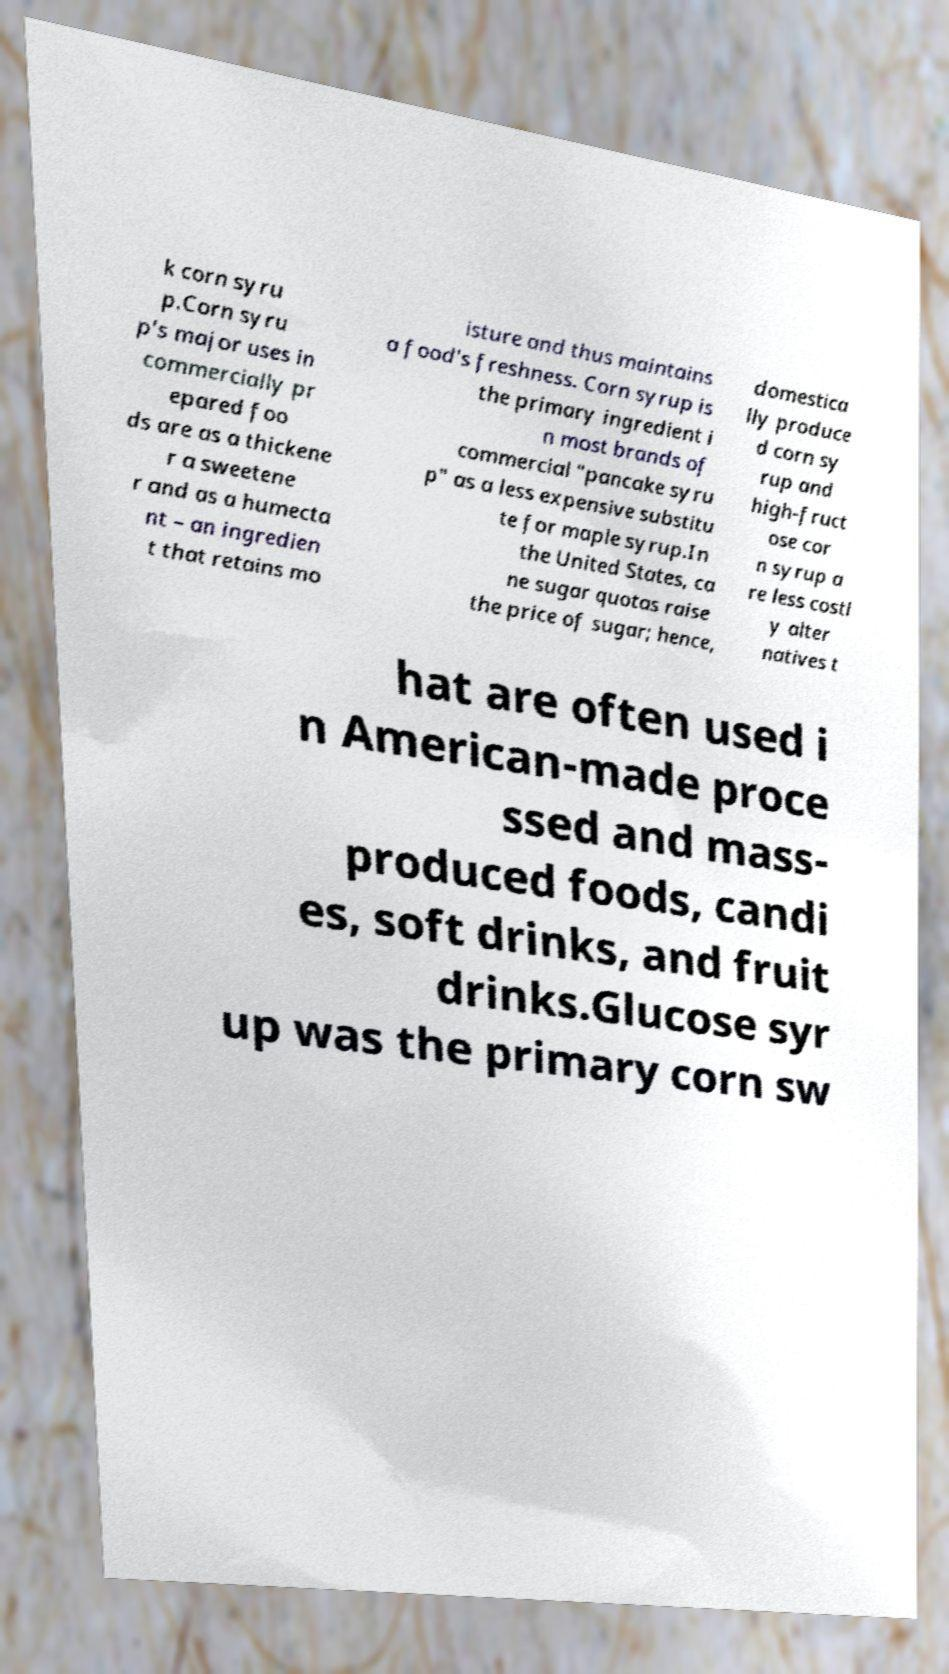Can you accurately transcribe the text from the provided image for me? k corn syru p.Corn syru p's major uses in commercially pr epared foo ds are as a thickene r a sweetene r and as a humecta nt – an ingredien t that retains mo isture and thus maintains a food's freshness. Corn syrup is the primary ingredient i n most brands of commercial "pancake syru p" as a less expensive substitu te for maple syrup.In the United States, ca ne sugar quotas raise the price of sugar; hence, domestica lly produce d corn sy rup and high-fruct ose cor n syrup a re less costl y alter natives t hat are often used i n American-made proce ssed and mass- produced foods, candi es, soft drinks, and fruit drinks.Glucose syr up was the primary corn sw 